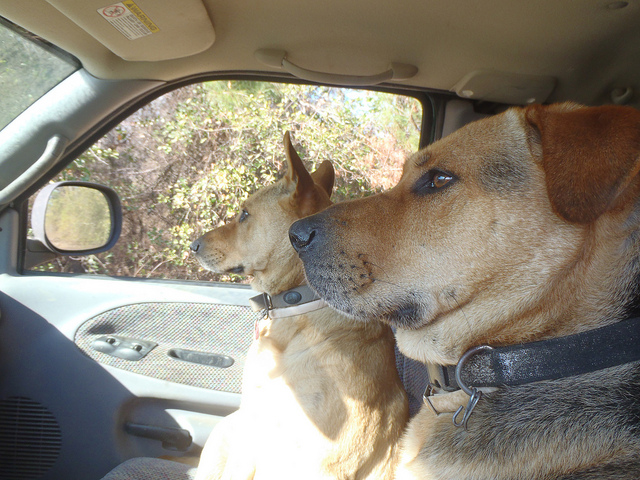Do the dogs look like they're on an adventure? Yes, the dogs have an alert and expectant expression, suggesting they might be on a trip or awaiting a fun activity, often signs of an adventure for dogs. 